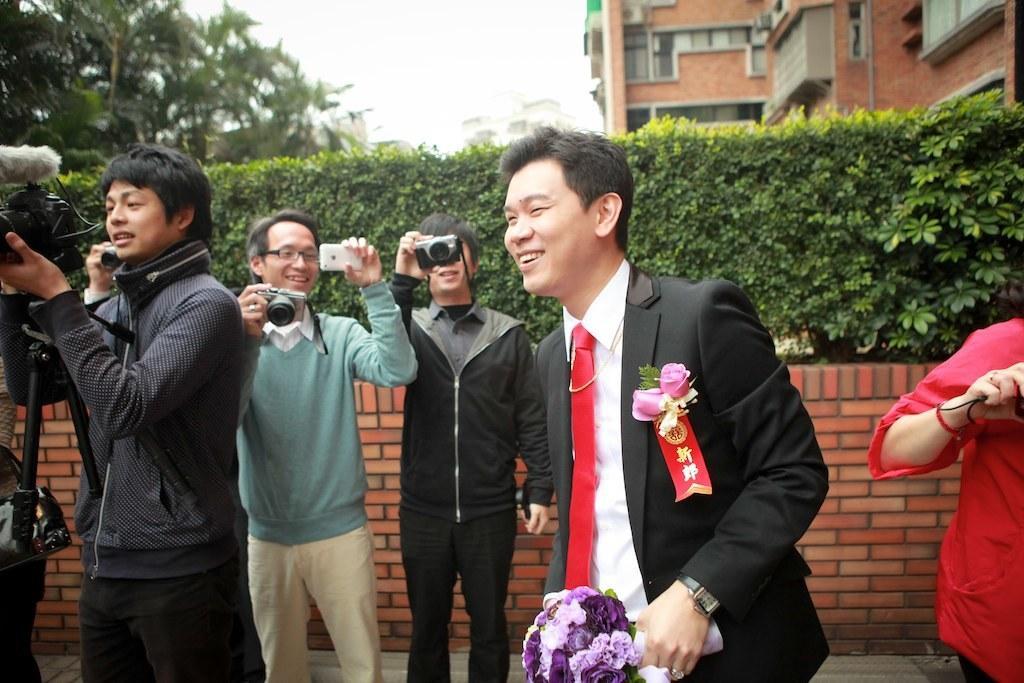Can you describe this image briefly? In this picture we can see a group of people standing on the ground where some are holding cameras with their hands and in the background we can see the sky. 